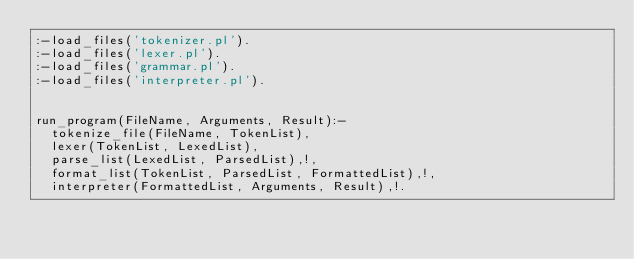Convert code to text. <code><loc_0><loc_0><loc_500><loc_500><_Perl_>:-load_files('tokenizer.pl').
:-load_files('lexer.pl').
:-load_files('grammar.pl').
:-load_files('interpreter.pl').


run_program(FileName, Arguments, Result):-
	tokenize_file(FileName, TokenList),
	lexer(TokenList, LexedList),
	parse_list(LexedList, ParsedList),!,
	format_list(TokenList, ParsedList, FormattedList),!,
	interpreter(FormattedList, Arguments, Result),!.

</code> 